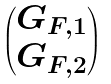<formula> <loc_0><loc_0><loc_500><loc_500>\begin{pmatrix} G _ { F , 1 } \\ G _ { F , 2 } \end{pmatrix}</formula> 